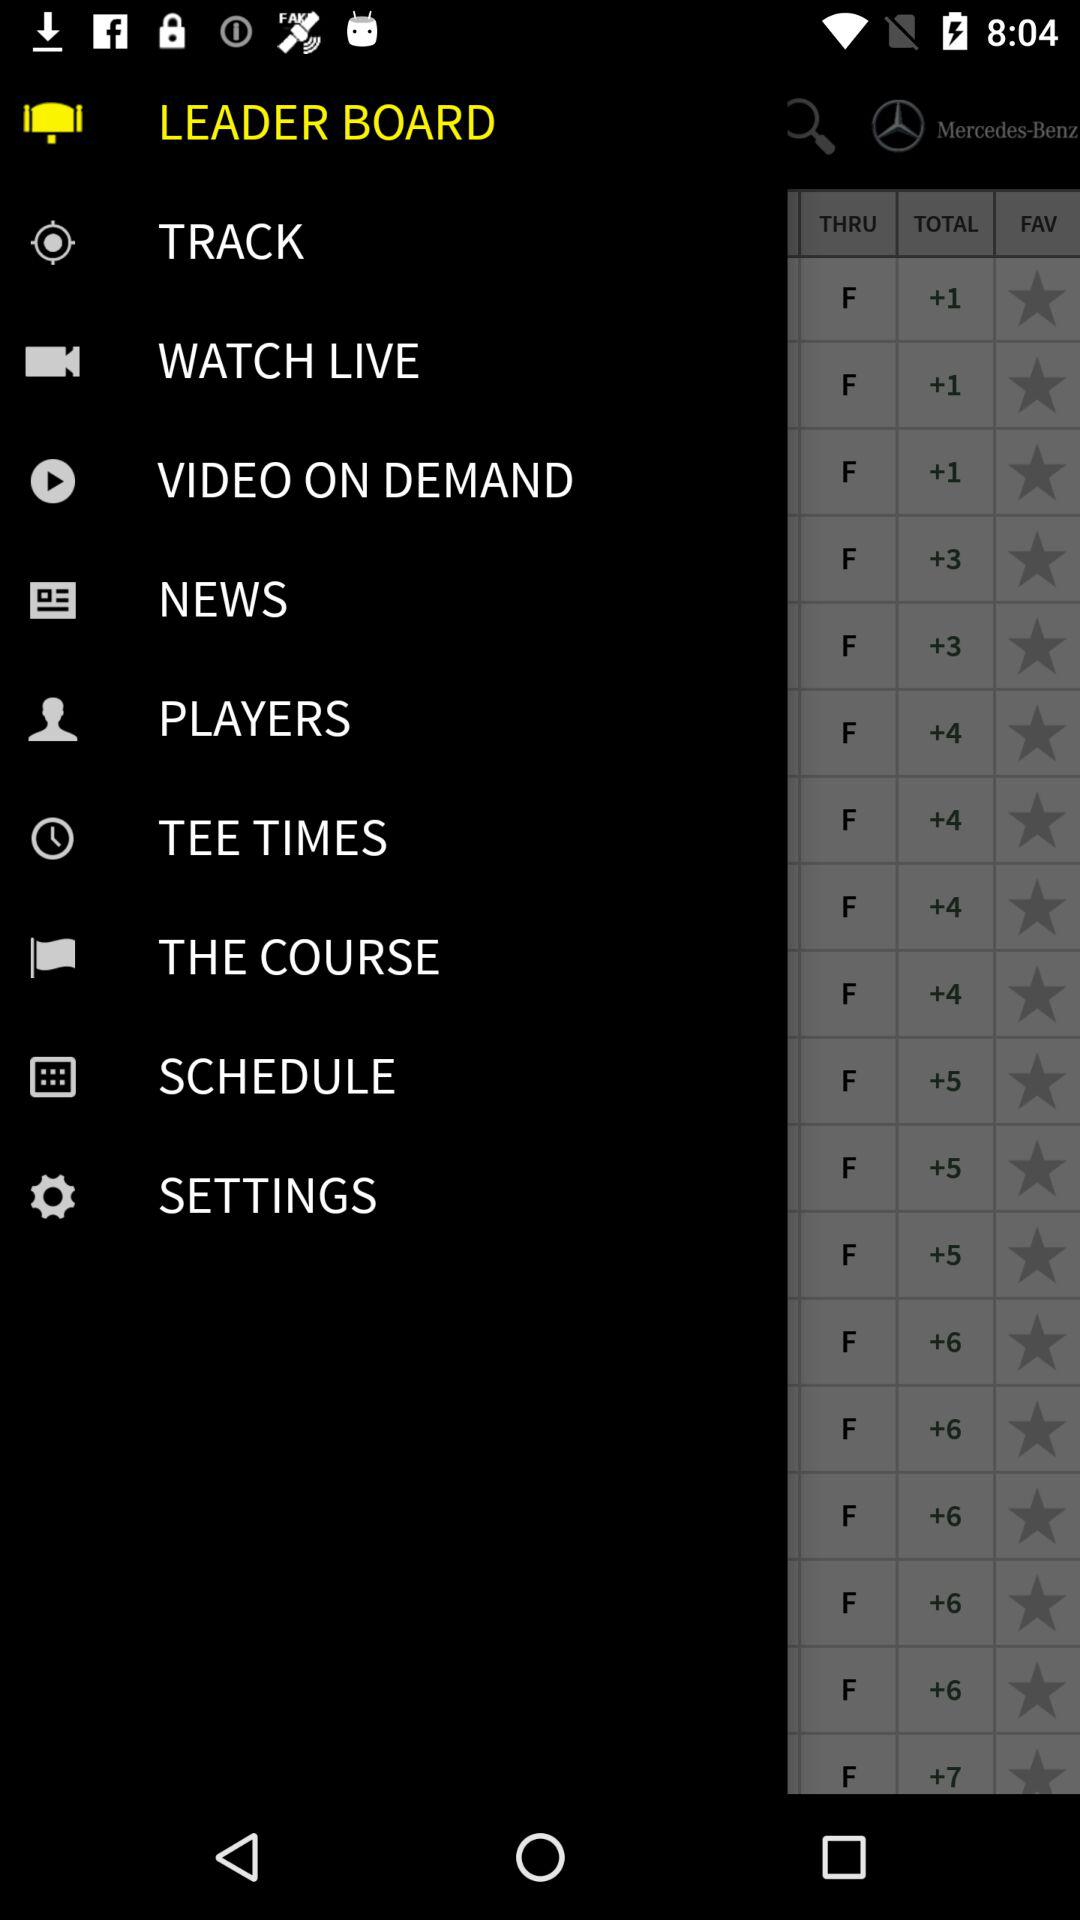What is the name of the application?
When the provided information is insufficient, respond with <no answer>. <no answer> 